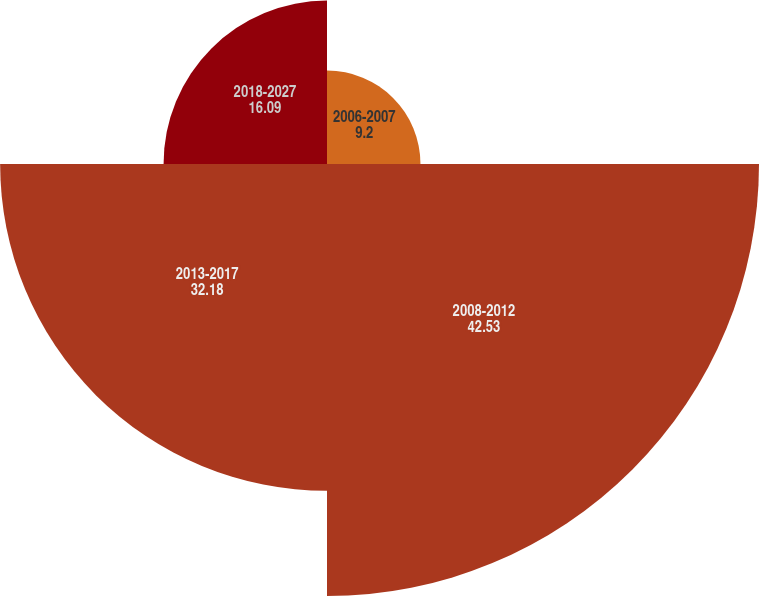<chart> <loc_0><loc_0><loc_500><loc_500><pie_chart><fcel>2006-2007<fcel>2008-2012<fcel>2013-2017<fcel>2018-2027<nl><fcel>9.2%<fcel>42.53%<fcel>32.18%<fcel>16.09%<nl></chart> 